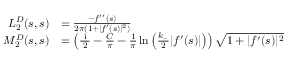Convert formula to latex. <formula><loc_0><loc_0><loc_500><loc_500>\begin{array} { r l } { L _ { 2 } ^ { D } ( s , s ) } & { = \frac { - f ^ { \prime \prime } ( s ) } { 2 \pi ( 1 + | f ^ { \prime } ( s ) | ^ { 2 } ) } } \\ { M _ { 2 } ^ { D } ( s , s ) } & { = \left ( \frac { i } { 2 } - \frac { C } { \pi } - \frac { 1 } { \pi } \ln \left ( \frac { k _ { - } } { 2 } | f ^ { \prime } ( s ) | \right ) \right ) \sqrt { 1 + | f ^ { \prime } ( s ) | ^ { 2 } } } \end{array}</formula> 